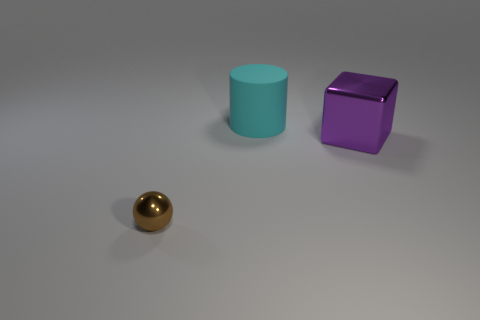Add 3 matte cylinders. How many objects exist? 6 Subtract all balls. How many objects are left? 2 Subtract 0 cyan balls. How many objects are left? 3 Subtract all big shiny blocks. Subtract all large gray rubber spheres. How many objects are left? 2 Add 3 big shiny things. How many big shiny things are left? 4 Add 1 large yellow metal cubes. How many large yellow metal cubes exist? 1 